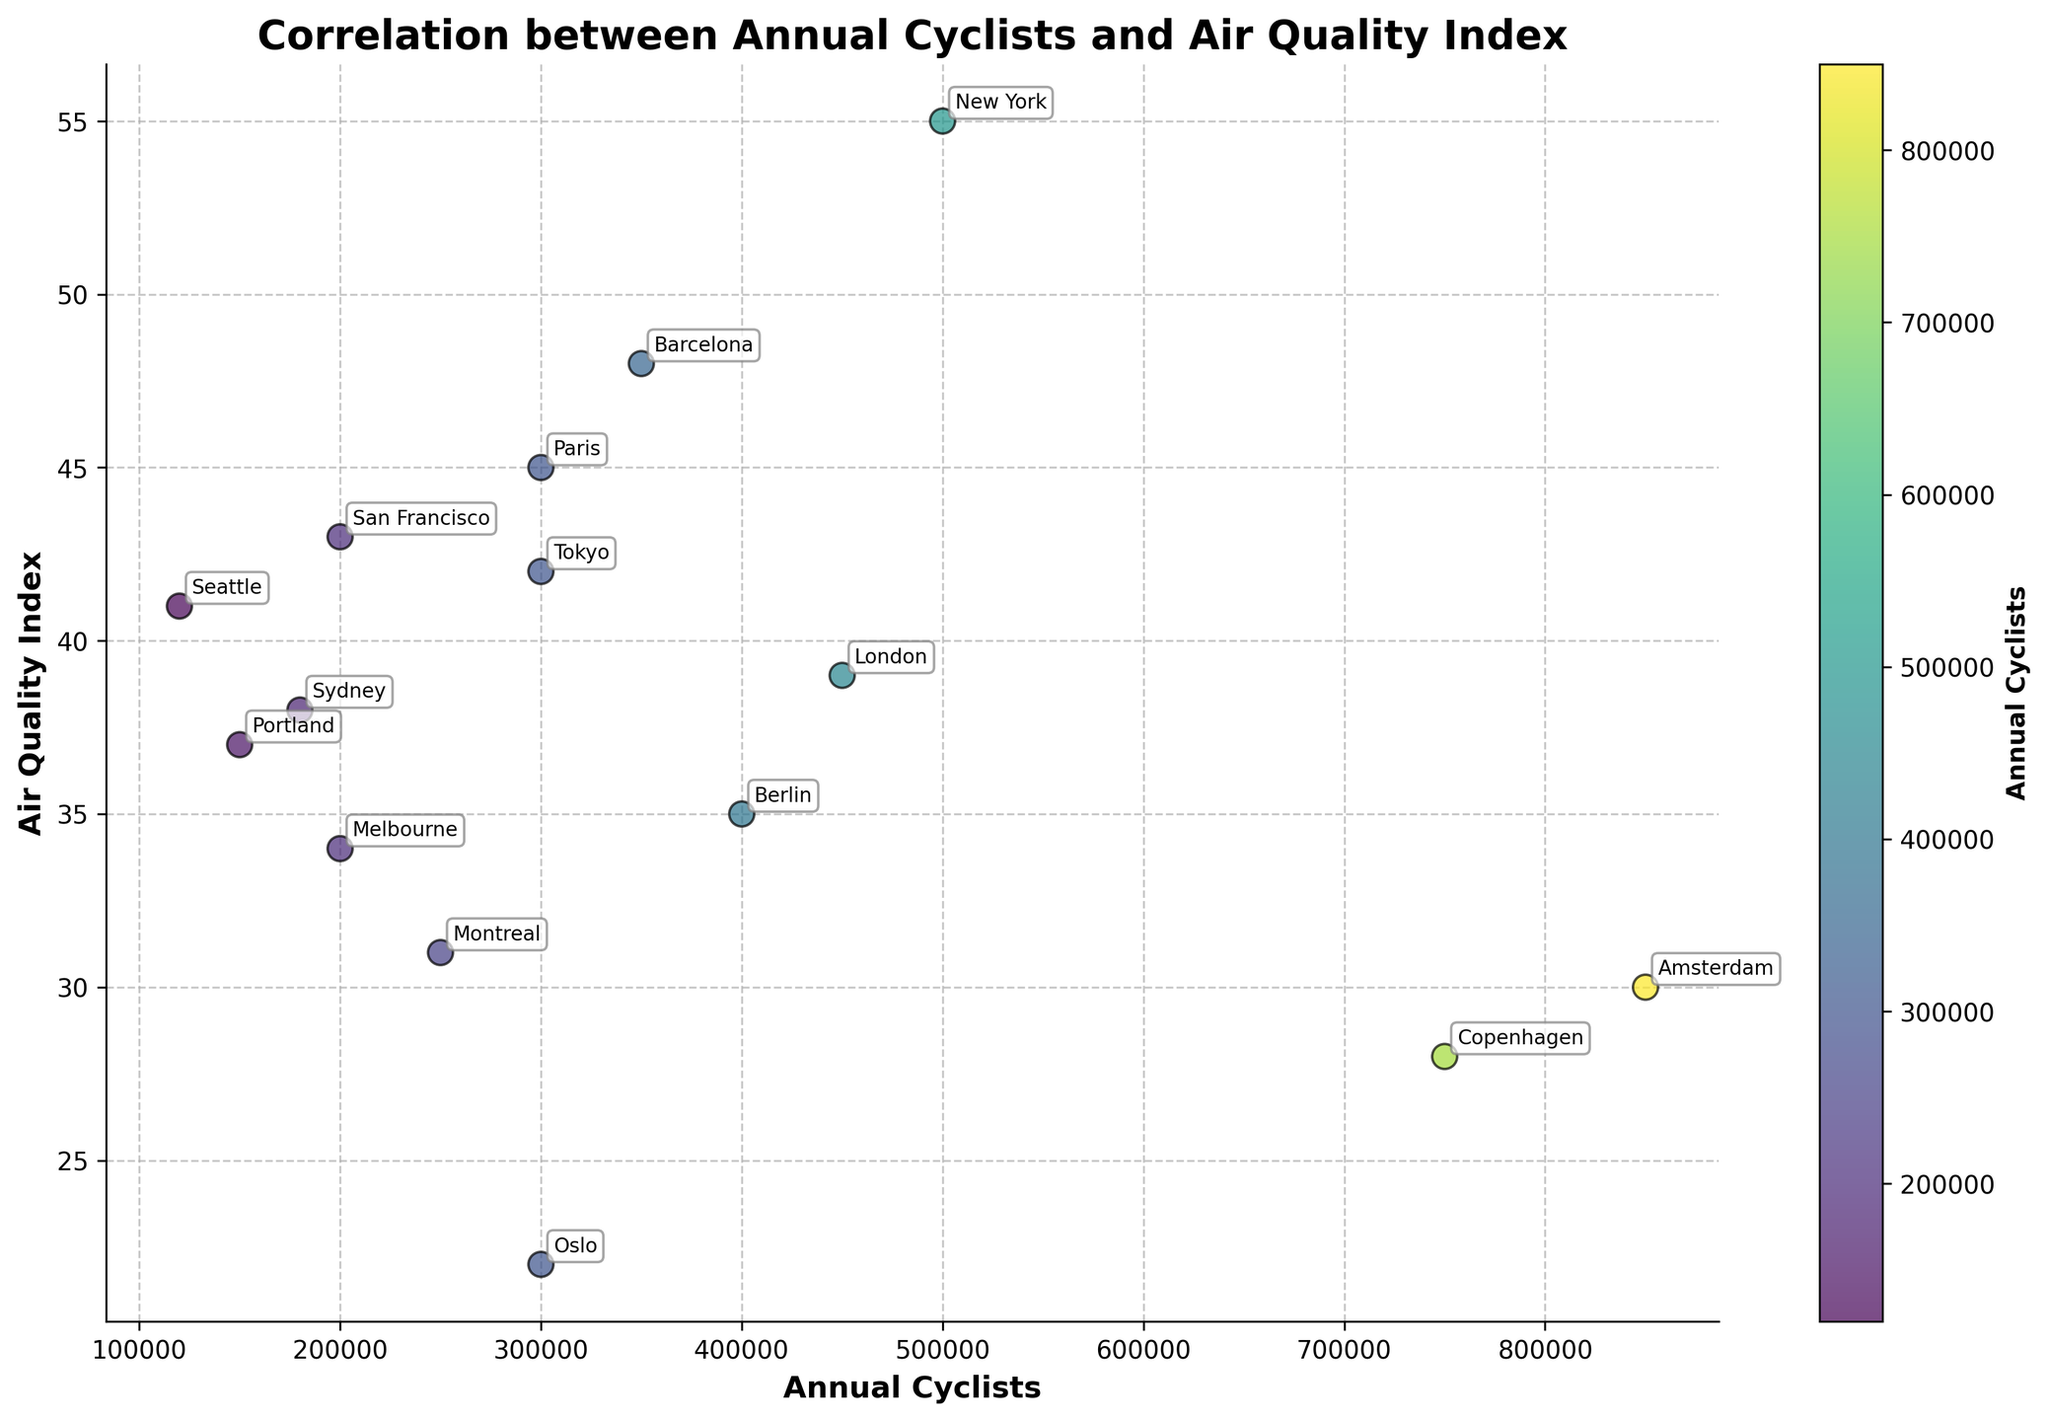What's the title of the plot? The title is located at the top of the plot.
Answer: Correlation between Annual Cyclists and Air Quality Index How many cities are represented in the plot? Count the number of data points, each representing a city.
Answer: 15 Which city has the highest number of annual cyclists? Look for the point farthest to the right on the x-axis.
Answer: Amsterdam What is the Air Quality Index of Berlin? Find the point labeled "Berlin" and read its position on the y-axis.
Answer: 35 Which city has the lowest Air Quality Index and what is its value? Find the point closest to the bottom of the y-axis and note its label and value.
Answer: Oslo, 22 How does the number of annual cyclists in Paris compare to that in London? Identify and compare the x-coordinates of the points labeled "Paris" and "London".
Answer: Paris has 150,000 fewer cyclists than London What is the average Air Quality Index of cities with over 400,000 cyclists? Identify the cities with more than 400,000 cyclists, sum their Air Quality Index values, and divide by the number of such cities (3).
Answer: (55 + 30 + 28) / 3 = 37.7 Are there any cities with more than 500,000 cyclists and an Air Quality Index above 40? Look for points to the right of 500,000 on the x-axis and above 40 on the y-axis.
Answer: No What color are the data points representing the cities? Observe the general color scheme used in the plot.
Answer: Different shades of green (viridis colormap) Which city has the closest Air Quality Index to 40? Identify the point with the y-coordinate closest to 40 and note its label.
Answer: San Francisco 